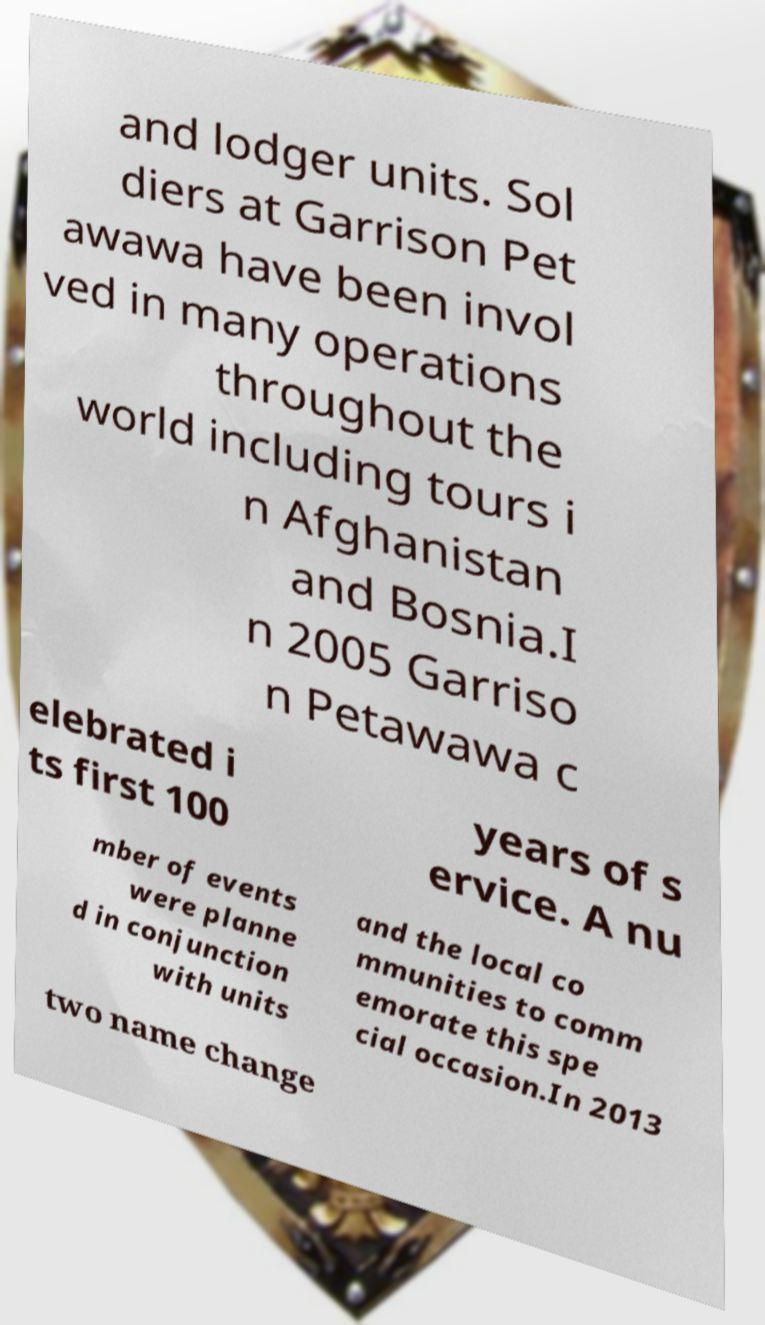Please read and relay the text visible in this image. What does it say? and lodger units. Sol diers at Garrison Pet awawa have been invol ved in many operations throughout the world including tours i n Afghanistan and Bosnia.I n 2005 Garriso n Petawawa c elebrated i ts first 100 years of s ervice. A nu mber of events were planne d in conjunction with units and the local co mmunities to comm emorate this spe cial occasion.In 2013 two name change 